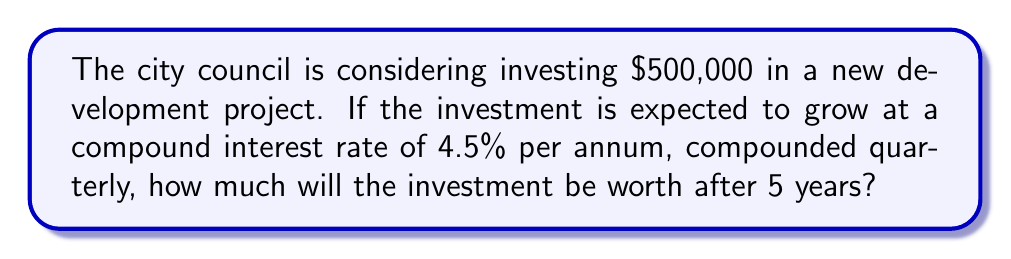Provide a solution to this math problem. To solve this problem, we'll use the compound interest formula:

$$A = P(1 + \frac{r}{n})^{nt}$$

Where:
$A$ = final amount
$P$ = principal (initial investment)
$r$ = annual interest rate (as a decimal)
$n$ = number of times interest is compounded per year
$t$ = time in years

Given:
$P = \$500,000$
$r = 4.5\% = 0.045$
$n = 4$ (compounded quarterly)
$t = 5$ years

Let's substitute these values into the formula:

$$A = 500,000(1 + \frac{0.045}{4})^{4(5)}$$

$$A = 500,000(1 + 0.01125)^{20}$$

$$A = 500,000(1.01125)^{20}$$

Using a calculator:

$$A = 500,000 \times 1.2511658$$

$$A = 625,582.90$$

Therefore, after 5 years, the investment will be worth $625,582.90.
Answer: $625,582.90 